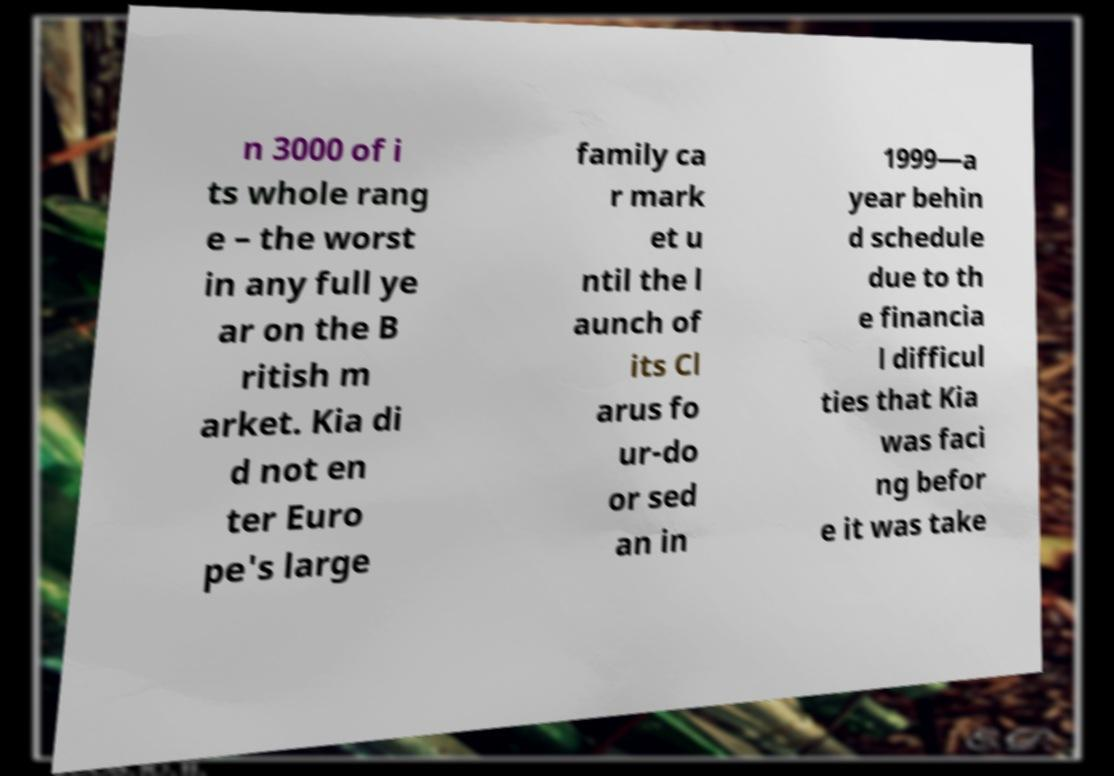Please read and relay the text visible in this image. What does it say? n 3000 of i ts whole rang e – the worst in any full ye ar on the B ritish m arket. Kia di d not en ter Euro pe's large family ca r mark et u ntil the l aunch of its Cl arus fo ur-do or sed an in 1999—a year behin d schedule due to th e financia l difficul ties that Kia was faci ng befor e it was take 